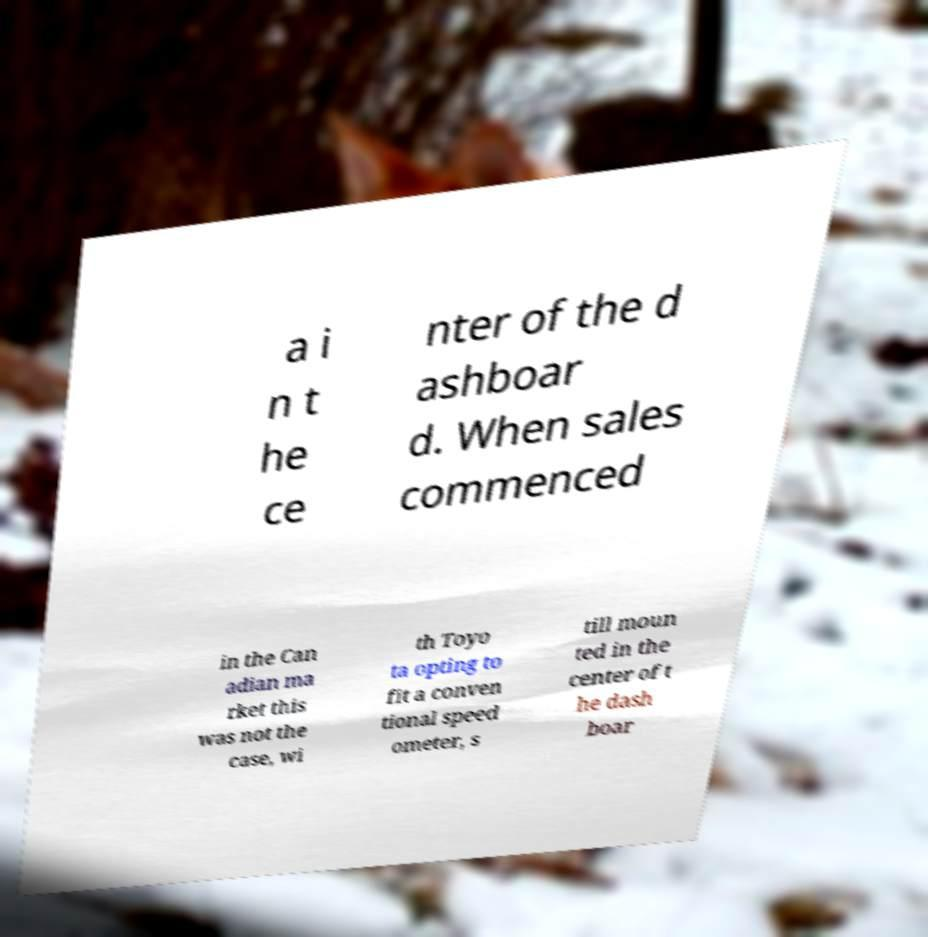For documentation purposes, I need the text within this image transcribed. Could you provide that? a i n t he ce nter of the d ashboar d. When sales commenced in the Can adian ma rket this was not the case, wi th Toyo ta opting to fit a conven tional speed ometer, s till moun ted in the center of t he dash boar 